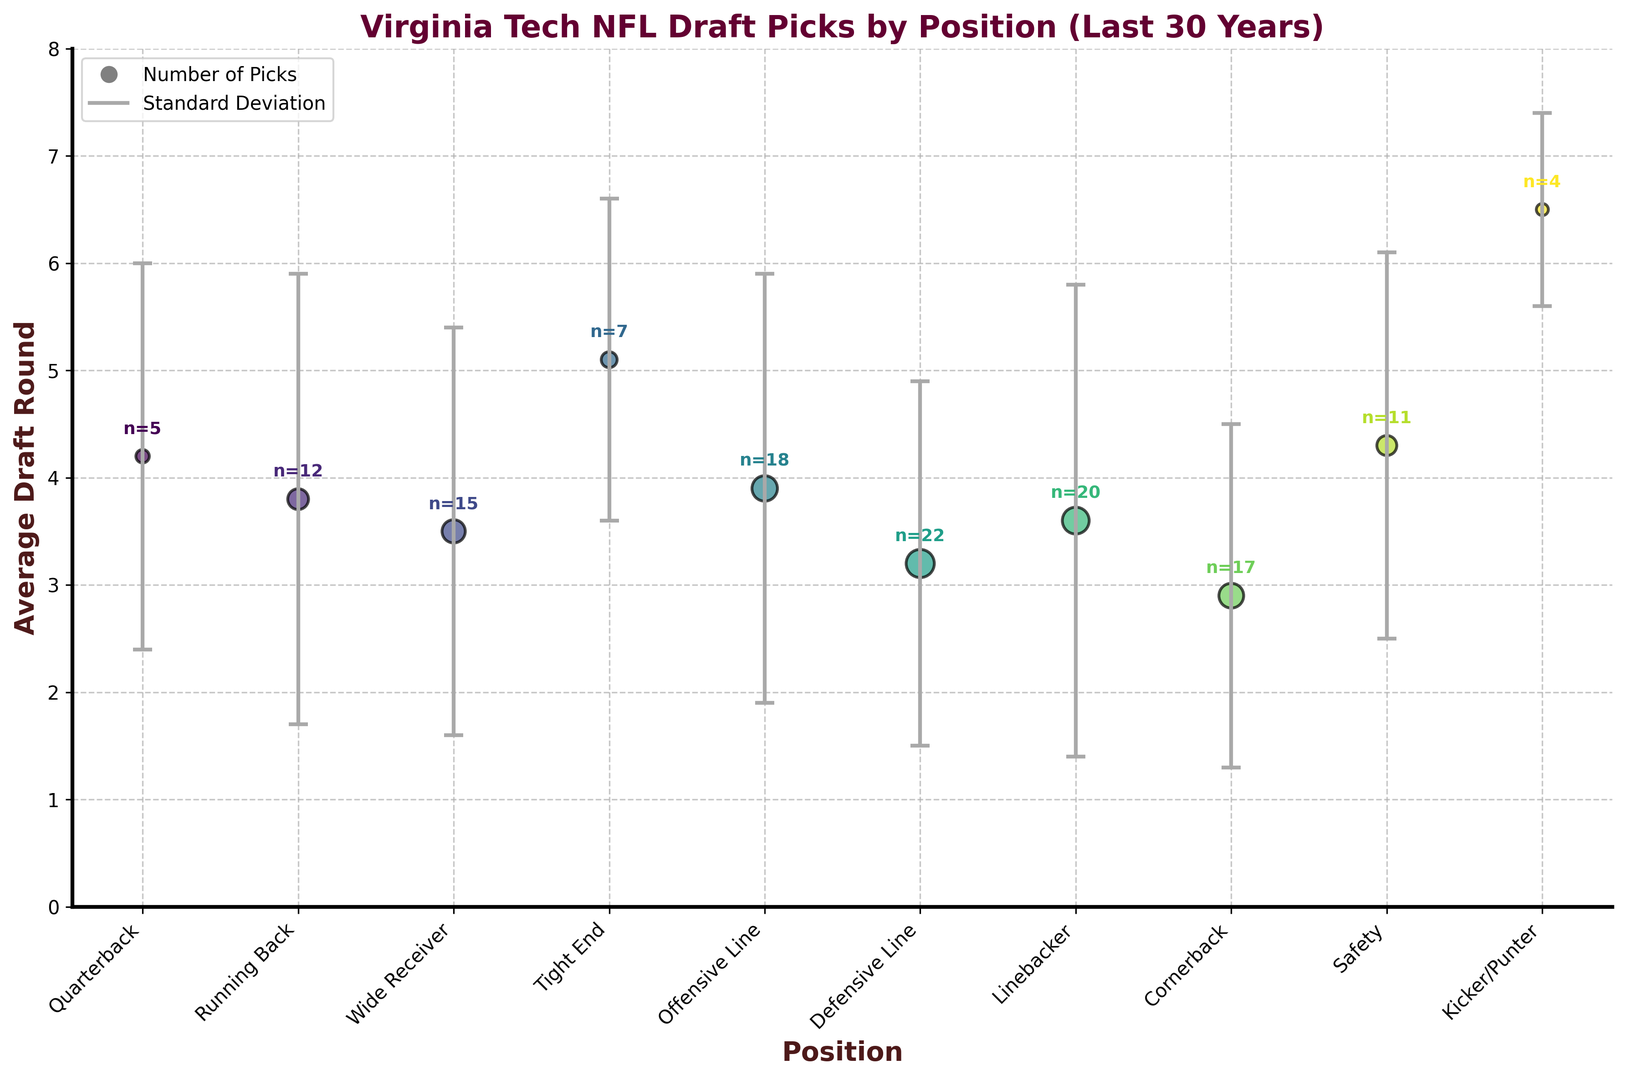What position group has the highest average draft round? Observe the y-axis values for each position and identify the bar that is the tallest, which corresponds to the highest average draft round. In this case, "Kicker/Punter" has the highest average draft round.
Answer: Kicker/Punter Which two position groups have the lowest variance in draft round selection? Identify the position groups with the shortest error bars, as smaller error bars indicate lower variance. "Kicker/Punter" and "Tight End" have the shortest error bars.
Answer: Kicker/Punter and Tight End How does the average draft round for Quarterbacks compare to that for Safeties? Identify the points for Quarterbacks and Safeties and compare their heights along the y-axis. Quarterbacks have an average draft round of 4.2, while Safeties have 4.3.
Answer: Quarterbacks are slightly lower What is the difference in average draft round between Wide Receivers and Cornerbacks? Refer to the y-axis values for both positions. Wide Receivers have an average draft round of 3.5, and Cornerbacks have 2.9. Subtract the lower value from the higher value. 3.5 - 2.9 = 0.6
Answer: 0.6 How many position groups have an average draft round below 4? Count the number of position group points that lie below the 4 mark on the y-axis. These are Defensive Line, Linebacker, Cornerback, Running Back, Wide Receiver, and Offensive Line.
Answer: 6 Which position group has the largest number of picks? Identify the position with the largest marker size, as larger markers correlate with a higher number of picks. "Defensive Line" has the largest marker size with 22 picks.
Answer: Defensive Line Between Running Backs and Linebackers, which group has a higher standard deviation in draft round selection? Compare the lengths of the error bars for Running Backs and Linebackers. Linebackers have a longer error bar, indicating a higher standard deviation.
Answer: Linebackers What's the sum of the average draft rounds for the top two positions with the most picks? Identify the positions with the highest number of picks, which are Defensive Line (22) and Linebacker (20). Their average draft rounds are 3.2 and 3.6 respectively. Add these values. 3.2 + 3.6 = 6.8
Answer: 6.8 Which position group has the second lowest average draft round? Identify the position bar with the second lowest value along the y-axis. The lowest is 2.9 for Cornerback, and the second lowest is 3.2 for Defensive Line.
Answer: Defensive Line For which position group is the difference between the average draft round and its standard deviation closest to zero? For each position group, subtract the standard deviation from the average draft round and find the smallest resultant value. The values are 4.2 - 1.8 = 2.4 (Quarterback), 3.8 - 2.1 = 1.7 (Running Back), 3.5 - 1.9 = 1.6 (Wide Receiver), 5.1 - 1.5 = 3.6 (Tight End), 3.9 - 2.0 = 1.9 (Offensive Line), 3.2 - 1.7 = 1.5 (Defensive Line), 3.6 - 2.2 = 1.4 (Linebacker), 2.9 - 1.6 = 1.3 (Cornerback), 4.3 - 1.8 = 2.5 (Safety), 6.5 - 0.9 = 5.6 (Kicker/Punter). "Cornerback" with value 1.3 is the closest.
Answer: Cornerback 